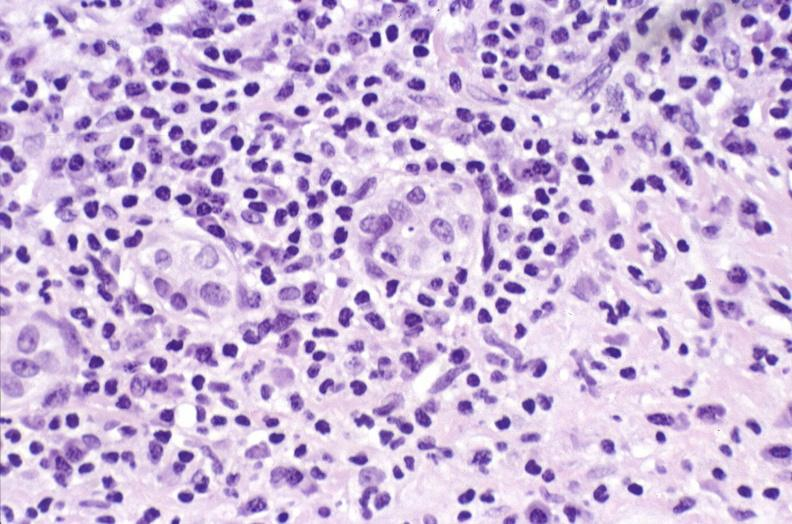does this image show primary biliary cirrhosis?
Answer the question using a single word or phrase. Yes 